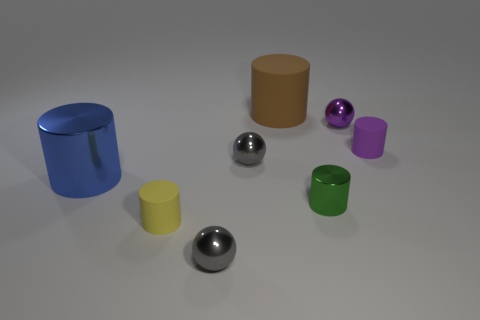How many things are both left of the green cylinder and in front of the small purple cylinder?
Provide a succinct answer. 4. Is there any other thing that is the same shape as the large matte thing?
Offer a very short reply. Yes. There is a big matte object; does it have the same color as the tiny rubber object in front of the large blue object?
Keep it short and to the point. No. What is the shape of the rubber object to the right of the small green shiny thing?
Offer a very short reply. Cylinder. What number of other things are the same material as the small yellow cylinder?
Offer a very short reply. 2. What material is the large brown cylinder?
Provide a short and direct response. Rubber. What number of tiny things are either matte things or gray metallic spheres?
Offer a very short reply. 4. There is a large rubber cylinder; what number of metal balls are on the right side of it?
Offer a very short reply. 1. Is there a big rubber thing of the same color as the large metallic cylinder?
Offer a very short reply. No. What shape is the blue shiny thing that is the same size as the brown matte cylinder?
Provide a succinct answer. Cylinder. 